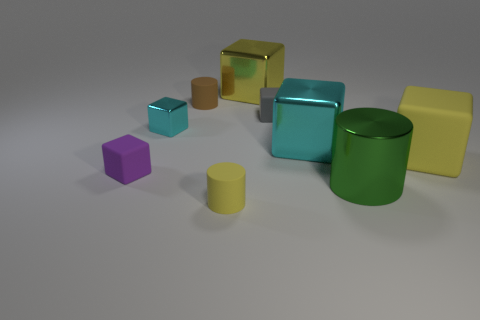Subtract all big cyan blocks. How many blocks are left? 5 Subtract all purple blocks. How many blocks are left? 5 Subtract 3 cubes. How many cubes are left? 3 Subtract all blue cubes. Subtract all red cylinders. How many cubes are left? 6 Add 1 yellow objects. How many objects exist? 10 Subtract all cubes. How many objects are left? 3 Subtract all large things. Subtract all purple matte objects. How many objects are left? 4 Add 8 small cyan metallic things. How many small cyan metallic things are left? 9 Add 7 tiny purple cylinders. How many tiny purple cylinders exist? 7 Subtract 0 purple cylinders. How many objects are left? 9 